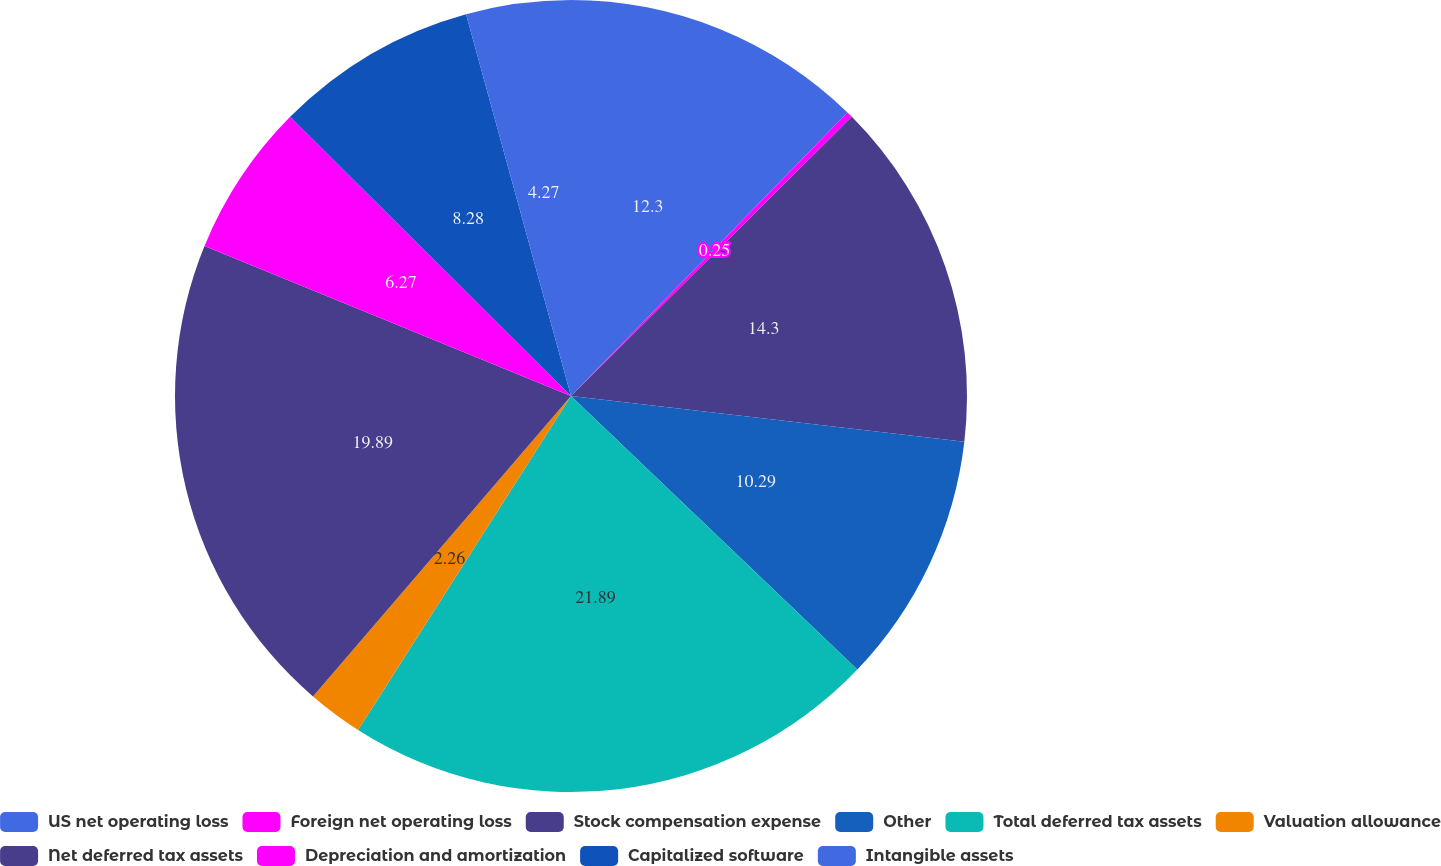<chart> <loc_0><loc_0><loc_500><loc_500><pie_chart><fcel>US net operating loss<fcel>Foreign net operating loss<fcel>Stock compensation expense<fcel>Other<fcel>Total deferred tax assets<fcel>Valuation allowance<fcel>Net deferred tax assets<fcel>Depreciation and amortization<fcel>Capitalized software<fcel>Intangible assets<nl><fcel>12.3%<fcel>0.25%<fcel>14.3%<fcel>10.29%<fcel>21.9%<fcel>2.26%<fcel>19.89%<fcel>6.27%<fcel>8.28%<fcel>4.27%<nl></chart> 